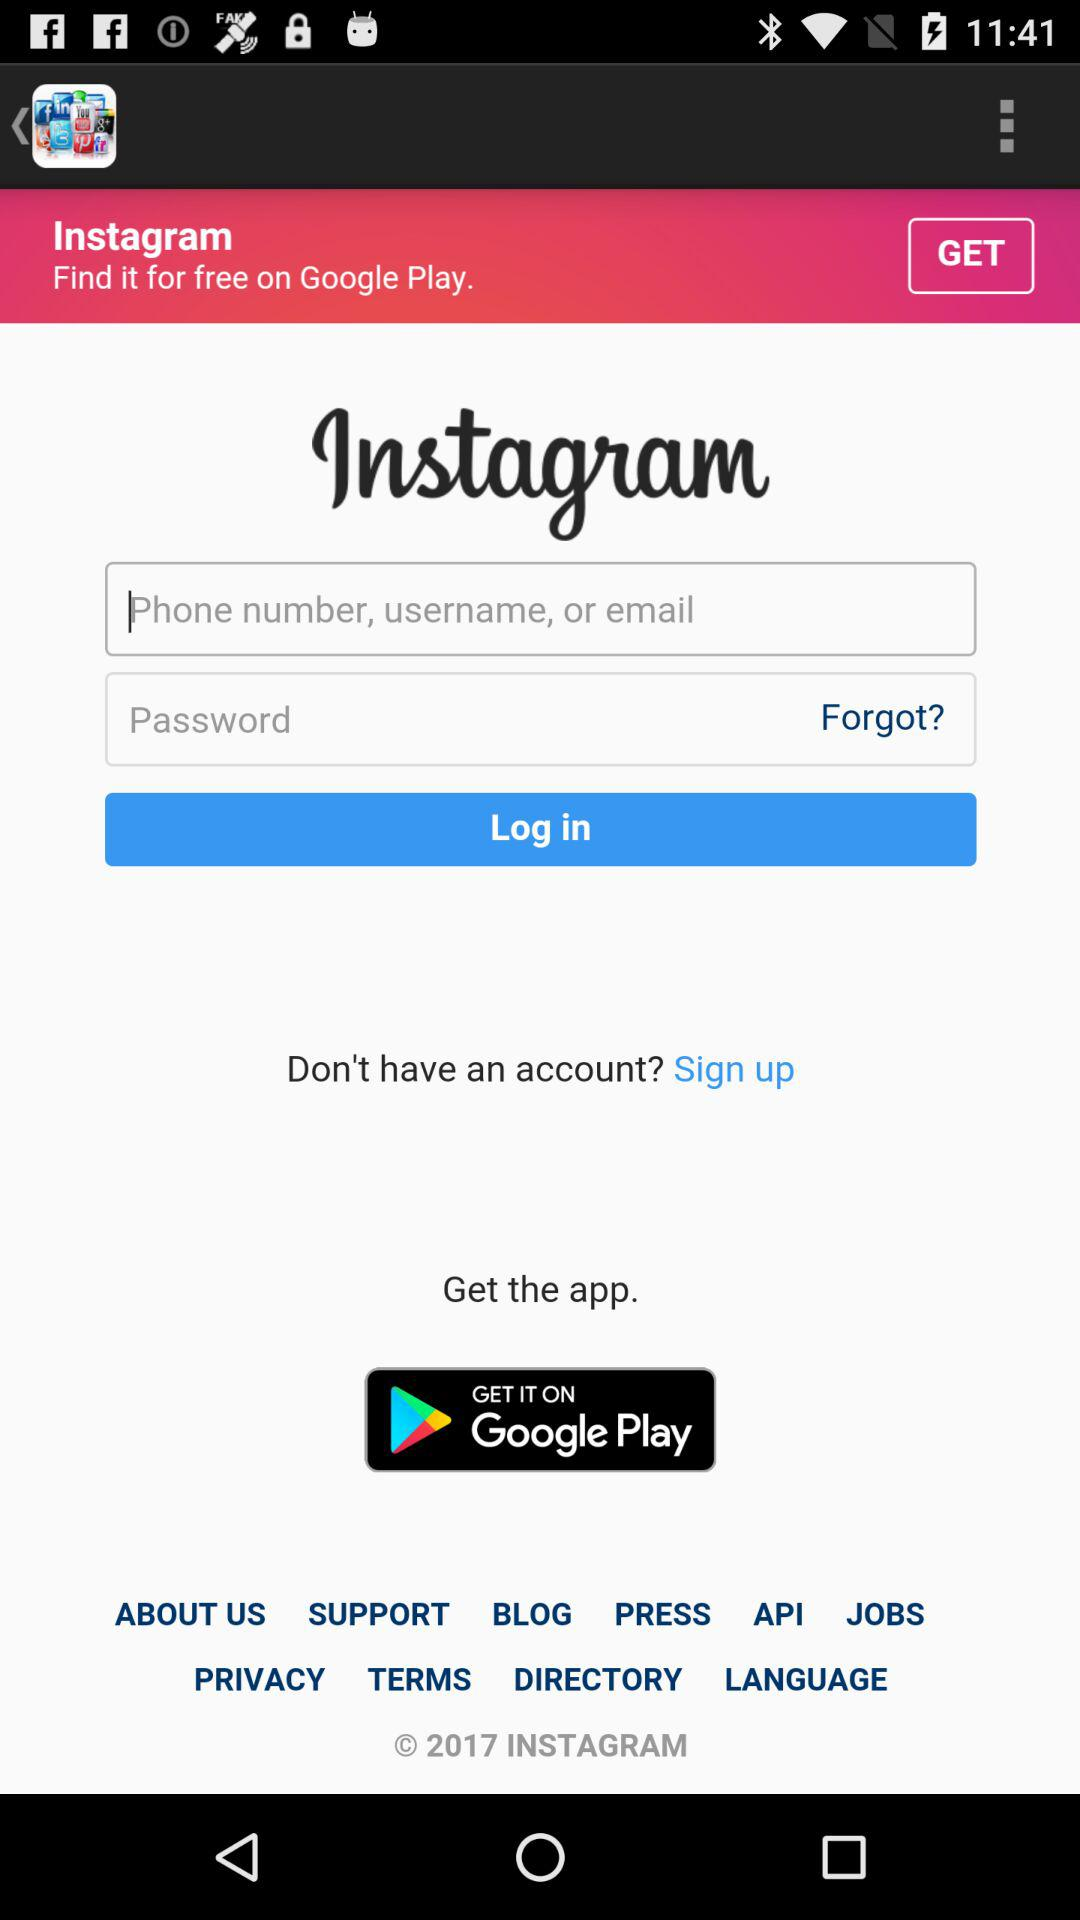What is the name of the application? The name of the application is "Instagram". 